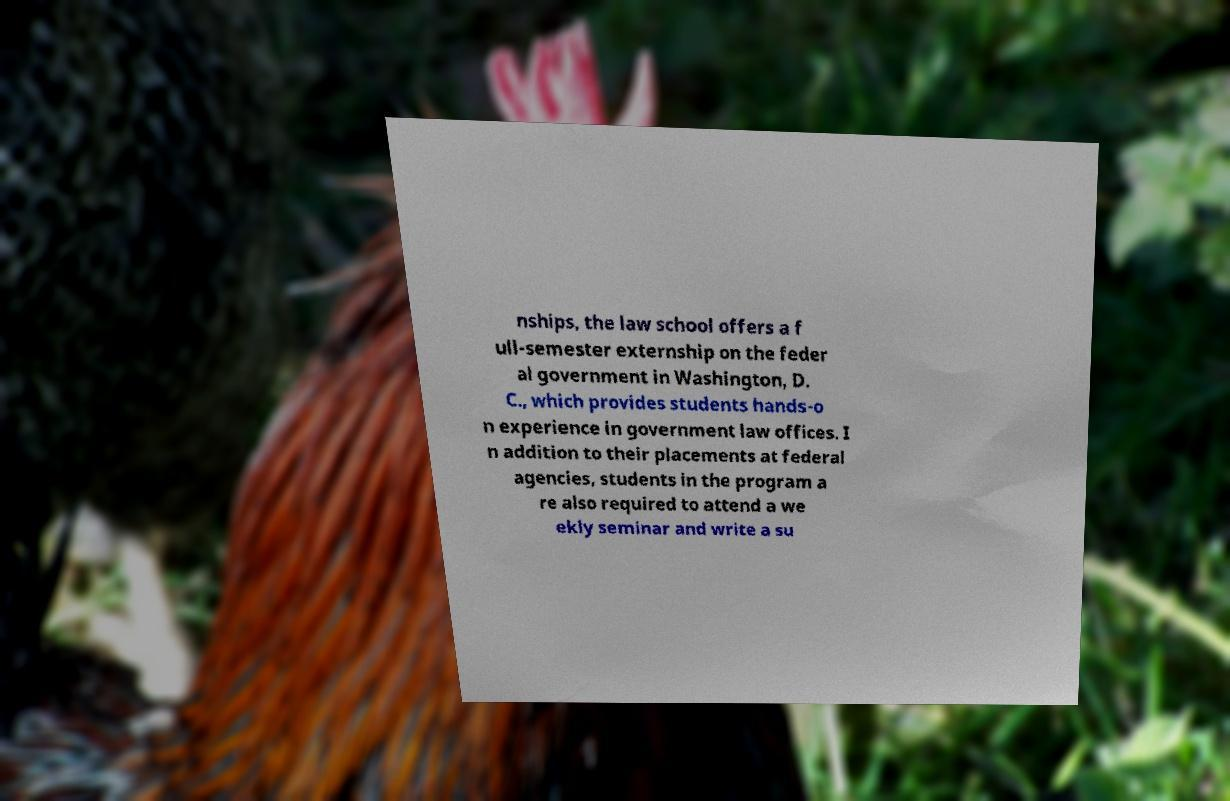Please identify and transcribe the text found in this image. nships, the law school offers a f ull-semester externship on the feder al government in Washington, D. C., which provides students hands-o n experience in government law offices. I n addition to their placements at federal agencies, students in the program a re also required to attend a we ekly seminar and write a su 